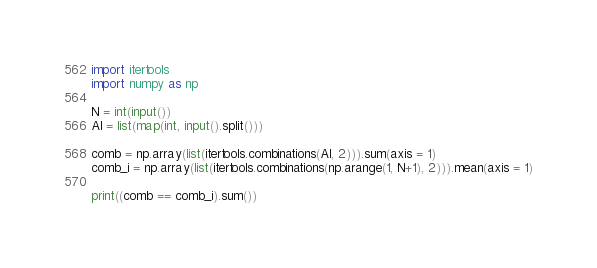<code> <loc_0><loc_0><loc_500><loc_500><_Python_>import itertools
import numpy as np

N = int(input())
Al = list(map(int, input().split()))

comb = np.array(list(itertools.combinations(Al, 2))).sum(axis = 1)
comb_i = np.array(list(itertools.combinations(np.arange(1, N+1), 2))).mean(axis = 1)

print((comb == comb_i).sum())</code> 